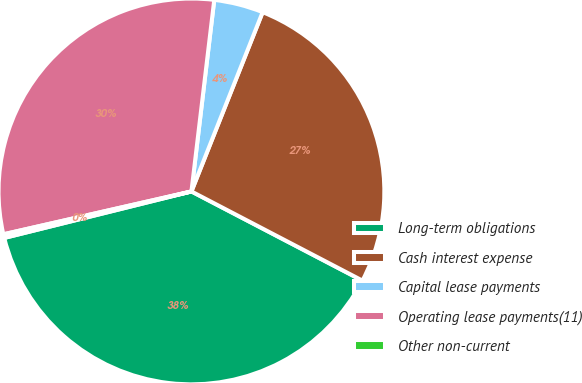<chart> <loc_0><loc_0><loc_500><loc_500><pie_chart><fcel>Long-term obligations<fcel>Cash interest expense<fcel>Capital lease payments<fcel>Operating lease payments(11)<fcel>Other non-current<nl><fcel>38.47%<fcel>26.63%<fcel>4.13%<fcel>30.45%<fcel>0.31%<nl></chart> 